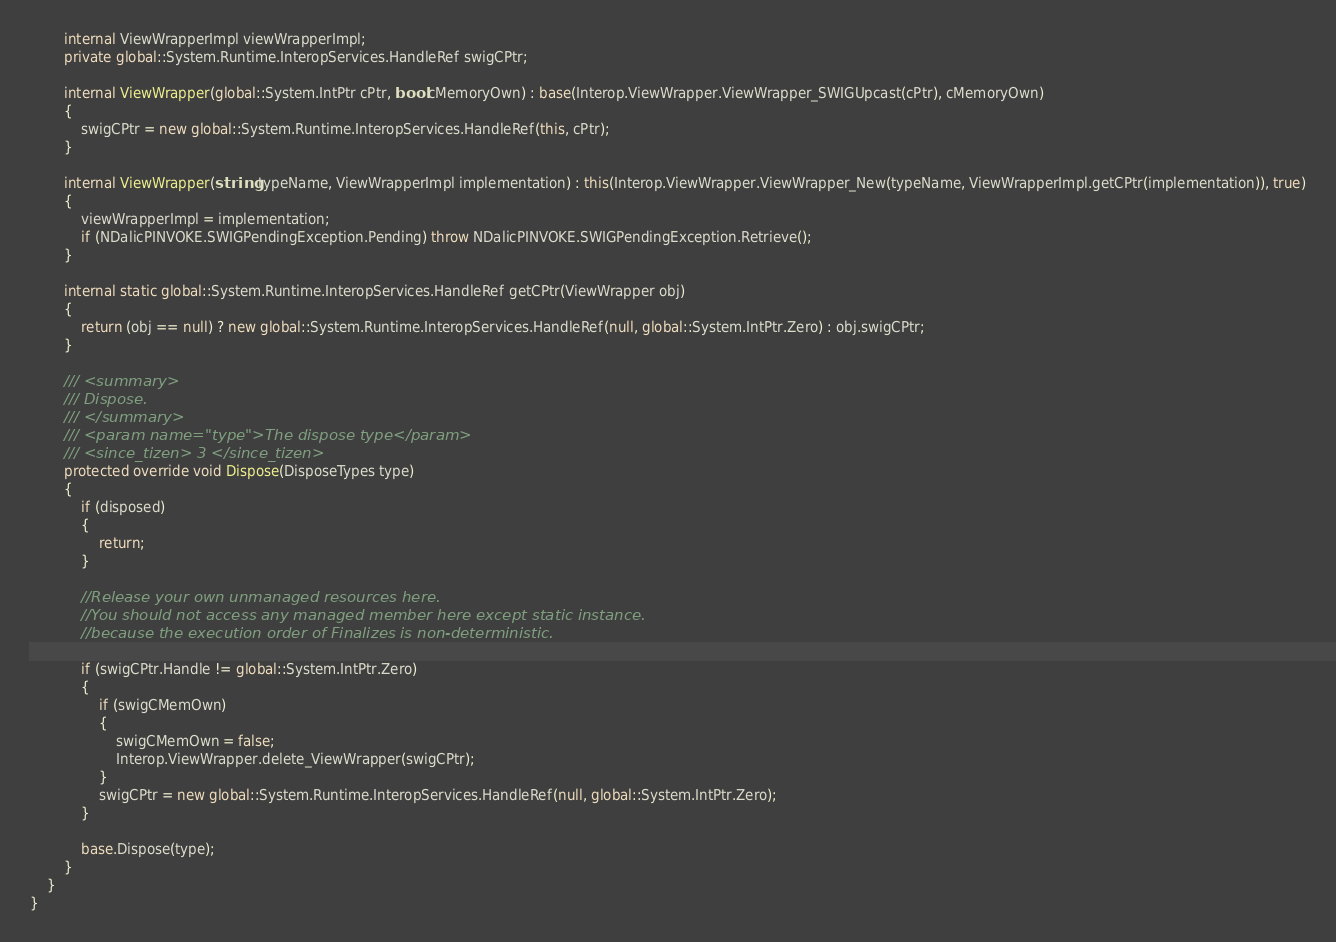<code> <loc_0><loc_0><loc_500><loc_500><_C#_>        internal ViewWrapperImpl viewWrapperImpl;
        private global::System.Runtime.InteropServices.HandleRef swigCPtr;

        internal ViewWrapper(global::System.IntPtr cPtr, bool cMemoryOwn) : base(Interop.ViewWrapper.ViewWrapper_SWIGUpcast(cPtr), cMemoryOwn)
        {
            swigCPtr = new global::System.Runtime.InteropServices.HandleRef(this, cPtr);
        }

        internal ViewWrapper(string typeName, ViewWrapperImpl implementation) : this(Interop.ViewWrapper.ViewWrapper_New(typeName, ViewWrapperImpl.getCPtr(implementation)), true)
        {
            viewWrapperImpl = implementation;
            if (NDalicPINVOKE.SWIGPendingException.Pending) throw NDalicPINVOKE.SWIGPendingException.Retrieve();
        }

        internal static global::System.Runtime.InteropServices.HandleRef getCPtr(ViewWrapper obj)
        {
            return (obj == null) ? new global::System.Runtime.InteropServices.HandleRef(null, global::System.IntPtr.Zero) : obj.swigCPtr;
        }

        /// <summary>
        /// Dispose.
        /// </summary>
        /// <param name="type">The dispose type</param>
        /// <since_tizen> 3 </since_tizen>
        protected override void Dispose(DisposeTypes type)
        {
            if (disposed)
            {
                return;
            }

            //Release your own unmanaged resources here.
            //You should not access any managed member here except static instance.
            //because the execution order of Finalizes is non-deterministic.

            if (swigCPtr.Handle != global::System.IntPtr.Zero)
            {
                if (swigCMemOwn)
                {
                    swigCMemOwn = false;
                    Interop.ViewWrapper.delete_ViewWrapper(swigCPtr);
                }
                swigCPtr = new global::System.Runtime.InteropServices.HandleRef(null, global::System.IntPtr.Zero);
            }

            base.Dispose(type);
        }
    }
}</code> 